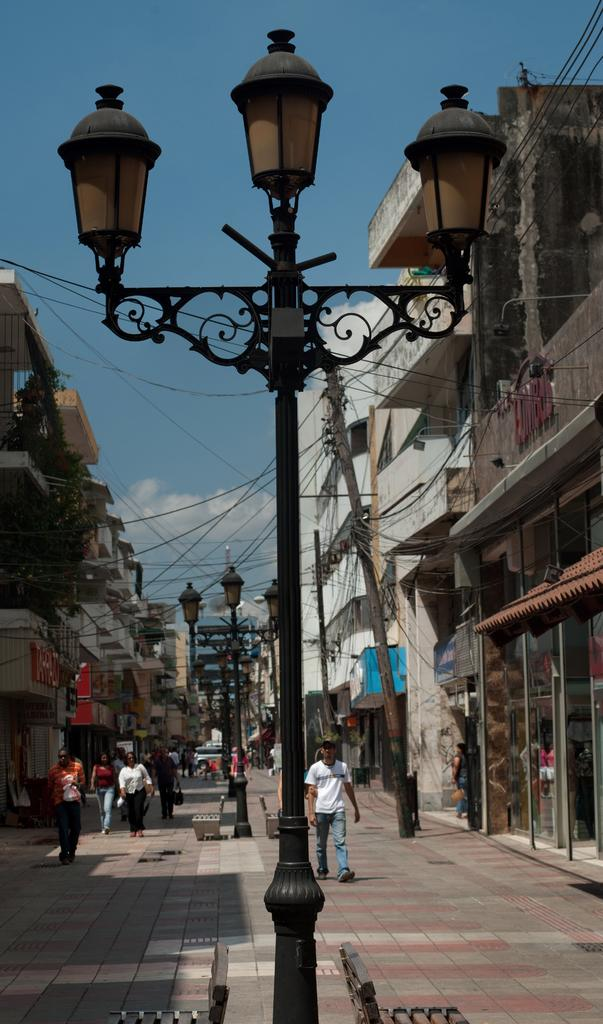What is the main object in the middle of the image? There is a pole with lights in the middle of the image. What can be seen happening in the background of the image? There are people walking in the background of the image. What type of structures are on either side of the image? There are buildings on either side of the image. What is visible at the top of the image? The sky is visible at the top of the image. What type of chair is being used to hold the milk in the image? There is no chair or milk present in the image. 